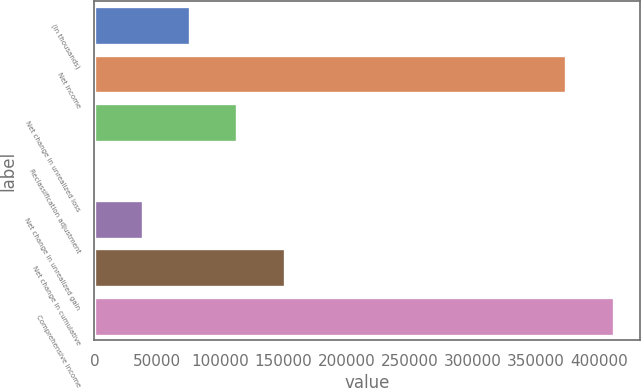Convert chart to OTSL. <chart><loc_0><loc_0><loc_500><loc_500><bar_chart><fcel>(In thousands)<fcel>Net income<fcel>Net change in unrealized loss<fcel>Reclassification adjustment<fcel>Net change in unrealized gain<fcel>Net change in cumulative<fcel>Comprehensive income<nl><fcel>75769.2<fcel>374047<fcel>113329<fcel>649<fcel>38209.1<fcel>150889<fcel>411607<nl></chart> 